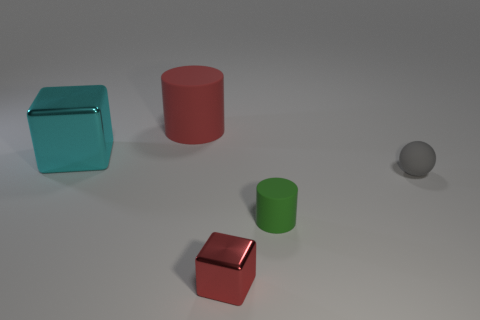How many metal blocks are the same color as the small sphere?
Give a very brief answer. 0. Is the number of big cyan metallic cubes less than the number of cyan matte spheres?
Your response must be concise. No. Is the large cyan object made of the same material as the large red object?
Provide a short and direct response. No. What number of other things are the same size as the red metallic block?
Offer a very short reply. 2. There is a block left of the large object to the right of the cyan metallic block; what is its color?
Offer a very short reply. Cyan. How many other objects are there of the same shape as the tiny red thing?
Provide a succinct answer. 1. Are there any red things that have the same material as the small green cylinder?
Your response must be concise. Yes. What is the material of the green cylinder that is the same size as the sphere?
Offer a terse response. Rubber. The cylinder on the left side of the red thing that is on the right side of the matte cylinder that is on the left side of the small cube is what color?
Provide a short and direct response. Red. Does the rubber object that is behind the large block have the same shape as the small green thing that is on the right side of the large metallic thing?
Offer a terse response. Yes. 